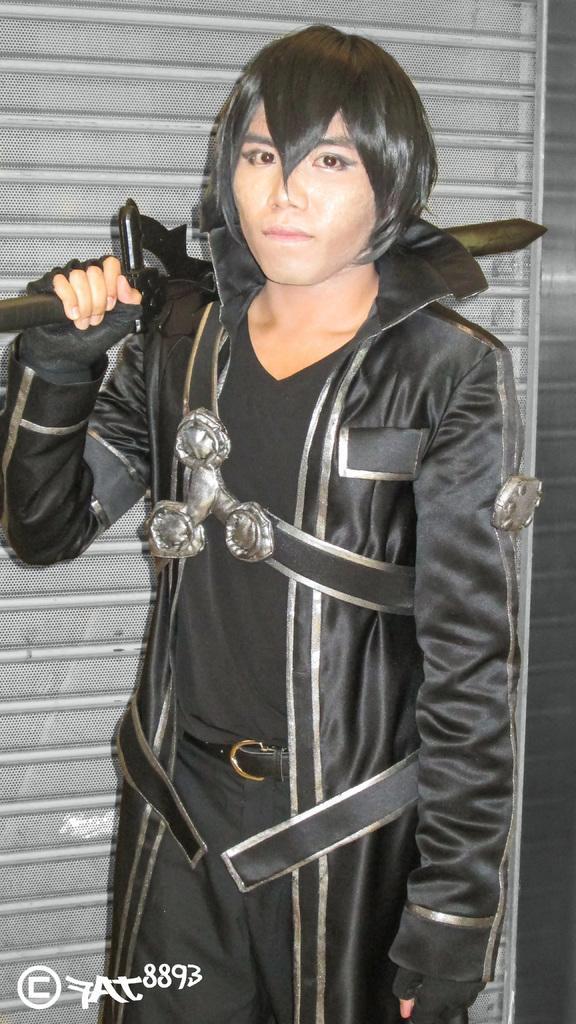Could you give a brief overview of what you see in this image? As we can see in the image there is a person wearing black color dress and holding sword. 